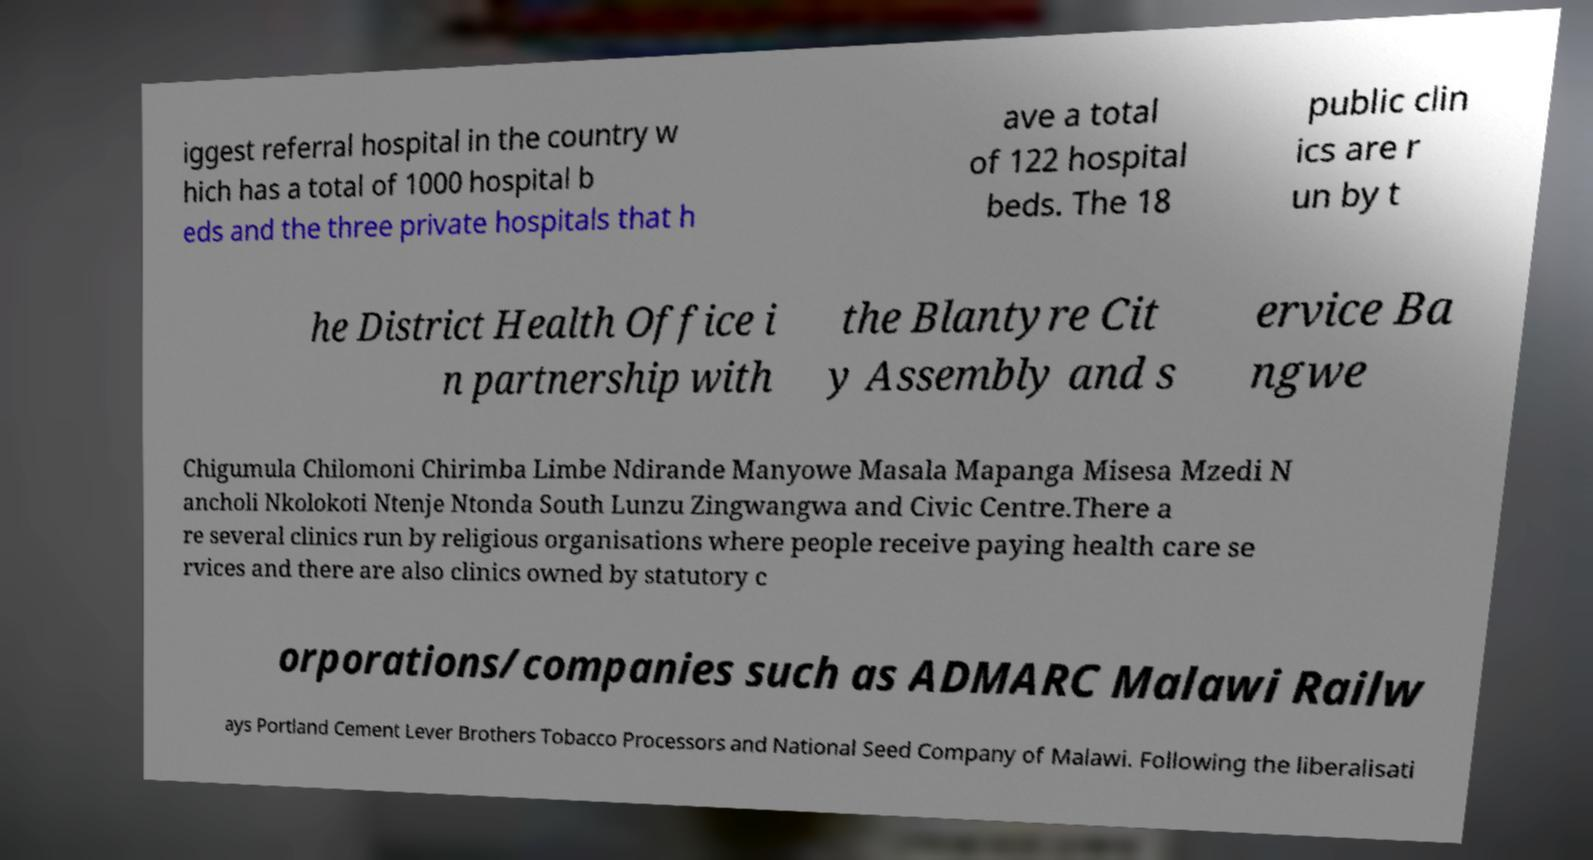There's text embedded in this image that I need extracted. Can you transcribe it verbatim? iggest referral hospital in the country w hich has a total of 1000 hospital b eds and the three private hospitals that h ave a total of 122 hospital beds. The 18 public clin ics are r un by t he District Health Office i n partnership with the Blantyre Cit y Assembly and s ervice Ba ngwe Chigumula Chilomoni Chirimba Limbe Ndirande Manyowe Masala Mapanga Misesa Mzedi N ancholi Nkolokoti Ntenje Ntonda South Lunzu Zingwangwa and Civic Centre.There a re several clinics run by religious organisations where people receive paying health care se rvices and there are also clinics owned by statutory c orporations/companies such as ADMARC Malawi Railw ays Portland Cement Lever Brothers Tobacco Processors and National Seed Company of Malawi. Following the liberalisati 